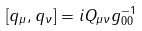Convert formula to latex. <formula><loc_0><loc_0><loc_500><loc_500>\left [ q _ { \mu } , q _ { \nu } \right ] = i Q _ { \mu \nu } g _ { 0 0 } ^ { - 1 }</formula> 